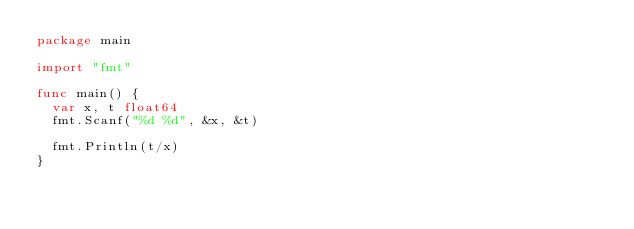<code> <loc_0><loc_0><loc_500><loc_500><_Go_>package main

import "fmt"

func main() {
  var x, t float64
  fmt.Scanf("%d %d", &x, &t)

  fmt.Println(t/x)
}
</code> 